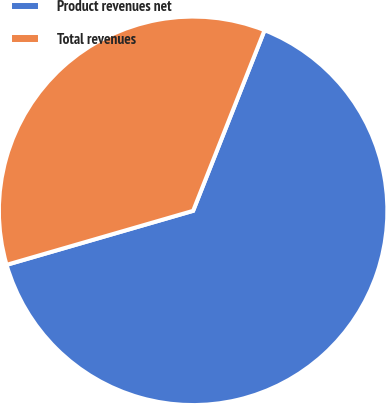<chart> <loc_0><loc_0><loc_500><loc_500><pie_chart><fcel>Product revenues net<fcel>Total revenues<nl><fcel>64.52%<fcel>35.48%<nl></chart> 